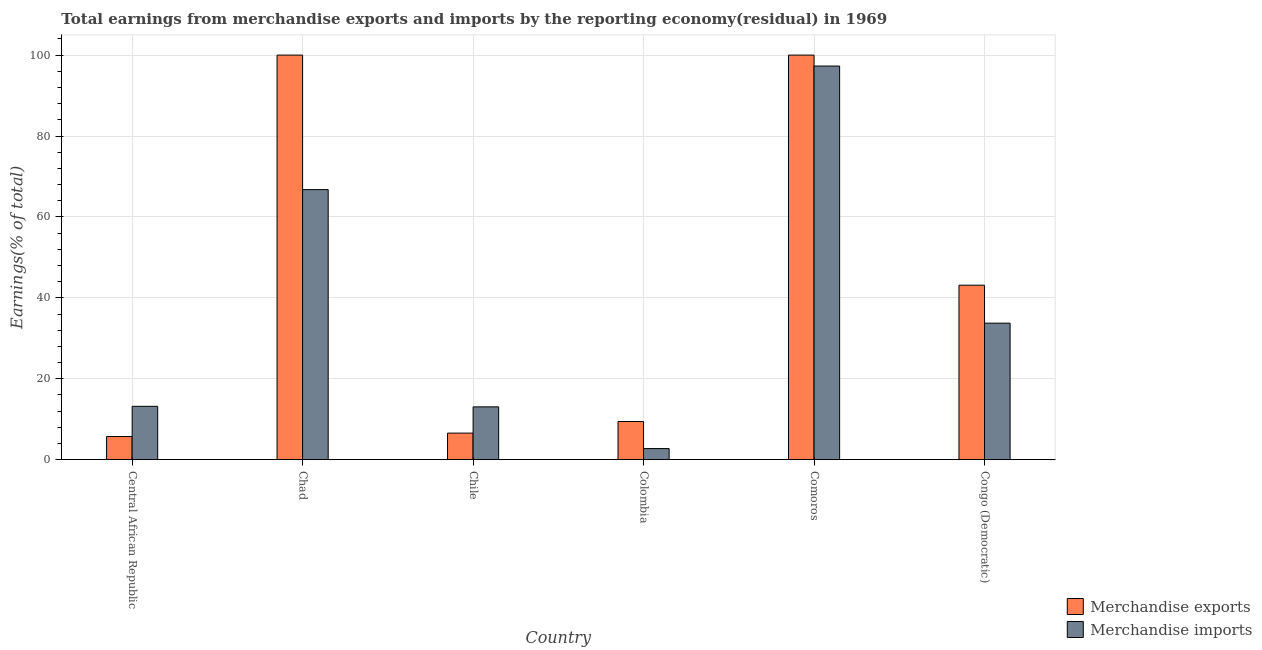How many groups of bars are there?
Make the answer very short. 6. How many bars are there on the 4th tick from the left?
Provide a short and direct response. 2. What is the label of the 6th group of bars from the left?
Your answer should be compact. Congo (Democratic). In how many cases, is the number of bars for a given country not equal to the number of legend labels?
Your response must be concise. 0. What is the earnings from merchandise exports in Chile?
Your answer should be very brief. 6.57. Across all countries, what is the maximum earnings from merchandise imports?
Offer a very short reply. 97.3. Across all countries, what is the minimum earnings from merchandise imports?
Provide a short and direct response. 2.75. In which country was the earnings from merchandise imports maximum?
Provide a succinct answer. Comoros. In which country was the earnings from merchandise exports minimum?
Provide a short and direct response. Central African Republic. What is the total earnings from merchandise exports in the graph?
Give a very brief answer. 264.87. What is the difference between the earnings from merchandise exports in Colombia and that in Congo (Democratic)?
Give a very brief answer. -33.69. What is the difference between the earnings from merchandise exports in Chile and the earnings from merchandise imports in Colombia?
Make the answer very short. 3.82. What is the average earnings from merchandise exports per country?
Provide a succinct answer. 44.14. What is the difference between the earnings from merchandise imports and earnings from merchandise exports in Central African Republic?
Offer a terse response. 7.47. In how many countries, is the earnings from merchandise exports greater than 56 %?
Offer a terse response. 2. What is the ratio of the earnings from merchandise exports in Chad to that in Colombia?
Make the answer very short. 10.59. Is the difference between the earnings from merchandise imports in Central African Republic and Chad greater than the difference between the earnings from merchandise exports in Central African Republic and Chad?
Offer a very short reply. Yes. What is the difference between the highest and the lowest earnings from merchandise exports?
Make the answer very short. 94.27. In how many countries, is the earnings from merchandise exports greater than the average earnings from merchandise exports taken over all countries?
Provide a short and direct response. 2. Is the sum of the earnings from merchandise imports in Comoros and Congo (Democratic) greater than the maximum earnings from merchandise exports across all countries?
Offer a terse response. Yes. What does the 2nd bar from the right in Chad represents?
Keep it short and to the point. Merchandise exports. Are all the bars in the graph horizontal?
Make the answer very short. No. How many countries are there in the graph?
Ensure brevity in your answer.  6. What is the difference between two consecutive major ticks on the Y-axis?
Your response must be concise. 20. Are the values on the major ticks of Y-axis written in scientific E-notation?
Ensure brevity in your answer.  No. Where does the legend appear in the graph?
Provide a succinct answer. Bottom right. How are the legend labels stacked?
Provide a short and direct response. Vertical. What is the title of the graph?
Make the answer very short. Total earnings from merchandise exports and imports by the reporting economy(residual) in 1969. Does "Working capital" appear as one of the legend labels in the graph?
Provide a succinct answer. No. What is the label or title of the X-axis?
Your answer should be compact. Country. What is the label or title of the Y-axis?
Offer a very short reply. Earnings(% of total). What is the Earnings(% of total) in Merchandise exports in Central African Republic?
Your answer should be compact. 5.73. What is the Earnings(% of total) in Merchandise imports in Central African Republic?
Your answer should be very brief. 13.19. What is the Earnings(% of total) of Merchandise imports in Chad?
Keep it short and to the point. 66.76. What is the Earnings(% of total) of Merchandise exports in Chile?
Offer a very short reply. 6.57. What is the Earnings(% of total) in Merchandise imports in Chile?
Offer a terse response. 13.06. What is the Earnings(% of total) in Merchandise exports in Colombia?
Ensure brevity in your answer.  9.44. What is the Earnings(% of total) in Merchandise imports in Colombia?
Ensure brevity in your answer.  2.75. What is the Earnings(% of total) in Merchandise exports in Comoros?
Offer a very short reply. 100. What is the Earnings(% of total) in Merchandise imports in Comoros?
Ensure brevity in your answer.  97.3. What is the Earnings(% of total) in Merchandise exports in Congo (Democratic)?
Provide a succinct answer. 43.13. What is the Earnings(% of total) of Merchandise imports in Congo (Democratic)?
Ensure brevity in your answer.  33.75. Across all countries, what is the maximum Earnings(% of total) of Merchandise exports?
Ensure brevity in your answer.  100. Across all countries, what is the maximum Earnings(% of total) in Merchandise imports?
Your response must be concise. 97.3. Across all countries, what is the minimum Earnings(% of total) of Merchandise exports?
Your answer should be very brief. 5.73. Across all countries, what is the minimum Earnings(% of total) of Merchandise imports?
Give a very brief answer. 2.75. What is the total Earnings(% of total) of Merchandise exports in the graph?
Provide a short and direct response. 264.87. What is the total Earnings(% of total) in Merchandise imports in the graph?
Give a very brief answer. 226.8. What is the difference between the Earnings(% of total) of Merchandise exports in Central African Republic and that in Chad?
Ensure brevity in your answer.  -94.27. What is the difference between the Earnings(% of total) of Merchandise imports in Central African Republic and that in Chad?
Keep it short and to the point. -53.56. What is the difference between the Earnings(% of total) in Merchandise exports in Central African Republic and that in Chile?
Offer a very short reply. -0.84. What is the difference between the Earnings(% of total) in Merchandise imports in Central African Republic and that in Chile?
Ensure brevity in your answer.  0.13. What is the difference between the Earnings(% of total) of Merchandise exports in Central African Republic and that in Colombia?
Provide a short and direct response. -3.71. What is the difference between the Earnings(% of total) of Merchandise imports in Central African Republic and that in Colombia?
Your answer should be very brief. 10.44. What is the difference between the Earnings(% of total) in Merchandise exports in Central African Republic and that in Comoros?
Your response must be concise. -94.27. What is the difference between the Earnings(% of total) of Merchandise imports in Central African Republic and that in Comoros?
Your answer should be very brief. -84.1. What is the difference between the Earnings(% of total) of Merchandise exports in Central African Republic and that in Congo (Democratic)?
Offer a terse response. -37.4. What is the difference between the Earnings(% of total) of Merchandise imports in Central African Republic and that in Congo (Democratic)?
Give a very brief answer. -20.55. What is the difference between the Earnings(% of total) of Merchandise exports in Chad and that in Chile?
Ensure brevity in your answer.  93.43. What is the difference between the Earnings(% of total) of Merchandise imports in Chad and that in Chile?
Your answer should be compact. 53.7. What is the difference between the Earnings(% of total) in Merchandise exports in Chad and that in Colombia?
Offer a terse response. 90.56. What is the difference between the Earnings(% of total) of Merchandise imports in Chad and that in Colombia?
Your answer should be compact. 64.01. What is the difference between the Earnings(% of total) of Merchandise imports in Chad and that in Comoros?
Offer a terse response. -30.54. What is the difference between the Earnings(% of total) in Merchandise exports in Chad and that in Congo (Democratic)?
Keep it short and to the point. 56.87. What is the difference between the Earnings(% of total) in Merchandise imports in Chad and that in Congo (Democratic)?
Provide a short and direct response. 33.01. What is the difference between the Earnings(% of total) in Merchandise exports in Chile and that in Colombia?
Give a very brief answer. -2.87. What is the difference between the Earnings(% of total) in Merchandise imports in Chile and that in Colombia?
Your response must be concise. 10.31. What is the difference between the Earnings(% of total) in Merchandise exports in Chile and that in Comoros?
Ensure brevity in your answer.  -93.43. What is the difference between the Earnings(% of total) in Merchandise imports in Chile and that in Comoros?
Offer a terse response. -84.24. What is the difference between the Earnings(% of total) of Merchandise exports in Chile and that in Congo (Democratic)?
Ensure brevity in your answer.  -36.56. What is the difference between the Earnings(% of total) in Merchandise imports in Chile and that in Congo (Democratic)?
Your response must be concise. -20.69. What is the difference between the Earnings(% of total) in Merchandise exports in Colombia and that in Comoros?
Your answer should be very brief. -90.56. What is the difference between the Earnings(% of total) of Merchandise imports in Colombia and that in Comoros?
Your response must be concise. -94.55. What is the difference between the Earnings(% of total) in Merchandise exports in Colombia and that in Congo (Democratic)?
Offer a very short reply. -33.69. What is the difference between the Earnings(% of total) in Merchandise imports in Colombia and that in Congo (Democratic)?
Provide a succinct answer. -31. What is the difference between the Earnings(% of total) of Merchandise exports in Comoros and that in Congo (Democratic)?
Your answer should be compact. 56.87. What is the difference between the Earnings(% of total) of Merchandise imports in Comoros and that in Congo (Democratic)?
Make the answer very short. 63.55. What is the difference between the Earnings(% of total) of Merchandise exports in Central African Republic and the Earnings(% of total) of Merchandise imports in Chad?
Offer a very short reply. -61.03. What is the difference between the Earnings(% of total) in Merchandise exports in Central African Republic and the Earnings(% of total) in Merchandise imports in Chile?
Provide a short and direct response. -7.33. What is the difference between the Earnings(% of total) of Merchandise exports in Central African Republic and the Earnings(% of total) of Merchandise imports in Colombia?
Your answer should be compact. 2.98. What is the difference between the Earnings(% of total) in Merchandise exports in Central African Republic and the Earnings(% of total) in Merchandise imports in Comoros?
Your answer should be compact. -91.57. What is the difference between the Earnings(% of total) of Merchandise exports in Central African Republic and the Earnings(% of total) of Merchandise imports in Congo (Democratic)?
Keep it short and to the point. -28.02. What is the difference between the Earnings(% of total) of Merchandise exports in Chad and the Earnings(% of total) of Merchandise imports in Chile?
Ensure brevity in your answer.  86.94. What is the difference between the Earnings(% of total) of Merchandise exports in Chad and the Earnings(% of total) of Merchandise imports in Colombia?
Keep it short and to the point. 97.25. What is the difference between the Earnings(% of total) of Merchandise exports in Chad and the Earnings(% of total) of Merchandise imports in Comoros?
Provide a short and direct response. 2.7. What is the difference between the Earnings(% of total) of Merchandise exports in Chad and the Earnings(% of total) of Merchandise imports in Congo (Democratic)?
Offer a terse response. 66.25. What is the difference between the Earnings(% of total) of Merchandise exports in Chile and the Earnings(% of total) of Merchandise imports in Colombia?
Your answer should be compact. 3.82. What is the difference between the Earnings(% of total) of Merchandise exports in Chile and the Earnings(% of total) of Merchandise imports in Comoros?
Your answer should be compact. -90.73. What is the difference between the Earnings(% of total) in Merchandise exports in Chile and the Earnings(% of total) in Merchandise imports in Congo (Democratic)?
Your response must be concise. -27.18. What is the difference between the Earnings(% of total) in Merchandise exports in Colombia and the Earnings(% of total) in Merchandise imports in Comoros?
Provide a short and direct response. -87.86. What is the difference between the Earnings(% of total) of Merchandise exports in Colombia and the Earnings(% of total) of Merchandise imports in Congo (Democratic)?
Offer a very short reply. -24.31. What is the difference between the Earnings(% of total) of Merchandise exports in Comoros and the Earnings(% of total) of Merchandise imports in Congo (Democratic)?
Offer a very short reply. 66.25. What is the average Earnings(% of total) of Merchandise exports per country?
Your response must be concise. 44.14. What is the average Earnings(% of total) in Merchandise imports per country?
Provide a succinct answer. 37.8. What is the difference between the Earnings(% of total) of Merchandise exports and Earnings(% of total) of Merchandise imports in Central African Republic?
Offer a terse response. -7.47. What is the difference between the Earnings(% of total) of Merchandise exports and Earnings(% of total) of Merchandise imports in Chad?
Your response must be concise. 33.24. What is the difference between the Earnings(% of total) in Merchandise exports and Earnings(% of total) in Merchandise imports in Chile?
Your answer should be compact. -6.49. What is the difference between the Earnings(% of total) in Merchandise exports and Earnings(% of total) in Merchandise imports in Colombia?
Make the answer very short. 6.69. What is the difference between the Earnings(% of total) in Merchandise exports and Earnings(% of total) in Merchandise imports in Comoros?
Your answer should be compact. 2.7. What is the difference between the Earnings(% of total) of Merchandise exports and Earnings(% of total) of Merchandise imports in Congo (Democratic)?
Offer a very short reply. 9.38. What is the ratio of the Earnings(% of total) in Merchandise exports in Central African Republic to that in Chad?
Your answer should be very brief. 0.06. What is the ratio of the Earnings(% of total) in Merchandise imports in Central African Republic to that in Chad?
Your response must be concise. 0.2. What is the ratio of the Earnings(% of total) of Merchandise exports in Central African Republic to that in Chile?
Provide a short and direct response. 0.87. What is the ratio of the Earnings(% of total) of Merchandise imports in Central African Republic to that in Chile?
Offer a very short reply. 1.01. What is the ratio of the Earnings(% of total) in Merchandise exports in Central African Republic to that in Colombia?
Provide a short and direct response. 0.61. What is the ratio of the Earnings(% of total) of Merchandise imports in Central African Republic to that in Colombia?
Provide a succinct answer. 4.8. What is the ratio of the Earnings(% of total) in Merchandise exports in Central African Republic to that in Comoros?
Provide a short and direct response. 0.06. What is the ratio of the Earnings(% of total) in Merchandise imports in Central African Republic to that in Comoros?
Offer a terse response. 0.14. What is the ratio of the Earnings(% of total) of Merchandise exports in Central African Republic to that in Congo (Democratic)?
Provide a short and direct response. 0.13. What is the ratio of the Earnings(% of total) of Merchandise imports in Central African Republic to that in Congo (Democratic)?
Give a very brief answer. 0.39. What is the ratio of the Earnings(% of total) of Merchandise exports in Chad to that in Chile?
Make the answer very short. 15.22. What is the ratio of the Earnings(% of total) of Merchandise imports in Chad to that in Chile?
Give a very brief answer. 5.11. What is the ratio of the Earnings(% of total) of Merchandise exports in Chad to that in Colombia?
Your answer should be compact. 10.59. What is the ratio of the Earnings(% of total) of Merchandise imports in Chad to that in Colombia?
Your response must be concise. 24.27. What is the ratio of the Earnings(% of total) in Merchandise exports in Chad to that in Comoros?
Offer a terse response. 1. What is the ratio of the Earnings(% of total) of Merchandise imports in Chad to that in Comoros?
Your answer should be compact. 0.69. What is the ratio of the Earnings(% of total) in Merchandise exports in Chad to that in Congo (Democratic)?
Your answer should be very brief. 2.32. What is the ratio of the Earnings(% of total) of Merchandise imports in Chad to that in Congo (Democratic)?
Your response must be concise. 1.98. What is the ratio of the Earnings(% of total) of Merchandise exports in Chile to that in Colombia?
Offer a very short reply. 0.7. What is the ratio of the Earnings(% of total) of Merchandise imports in Chile to that in Colombia?
Keep it short and to the point. 4.75. What is the ratio of the Earnings(% of total) of Merchandise exports in Chile to that in Comoros?
Your answer should be compact. 0.07. What is the ratio of the Earnings(% of total) in Merchandise imports in Chile to that in Comoros?
Provide a succinct answer. 0.13. What is the ratio of the Earnings(% of total) of Merchandise exports in Chile to that in Congo (Democratic)?
Provide a short and direct response. 0.15. What is the ratio of the Earnings(% of total) of Merchandise imports in Chile to that in Congo (Democratic)?
Give a very brief answer. 0.39. What is the ratio of the Earnings(% of total) in Merchandise exports in Colombia to that in Comoros?
Offer a terse response. 0.09. What is the ratio of the Earnings(% of total) in Merchandise imports in Colombia to that in Comoros?
Your response must be concise. 0.03. What is the ratio of the Earnings(% of total) of Merchandise exports in Colombia to that in Congo (Democratic)?
Provide a succinct answer. 0.22. What is the ratio of the Earnings(% of total) in Merchandise imports in Colombia to that in Congo (Democratic)?
Ensure brevity in your answer.  0.08. What is the ratio of the Earnings(% of total) in Merchandise exports in Comoros to that in Congo (Democratic)?
Provide a succinct answer. 2.32. What is the ratio of the Earnings(% of total) of Merchandise imports in Comoros to that in Congo (Democratic)?
Offer a very short reply. 2.88. What is the difference between the highest and the second highest Earnings(% of total) of Merchandise exports?
Your answer should be compact. 0. What is the difference between the highest and the second highest Earnings(% of total) in Merchandise imports?
Provide a short and direct response. 30.54. What is the difference between the highest and the lowest Earnings(% of total) of Merchandise exports?
Provide a short and direct response. 94.27. What is the difference between the highest and the lowest Earnings(% of total) of Merchandise imports?
Your answer should be very brief. 94.55. 